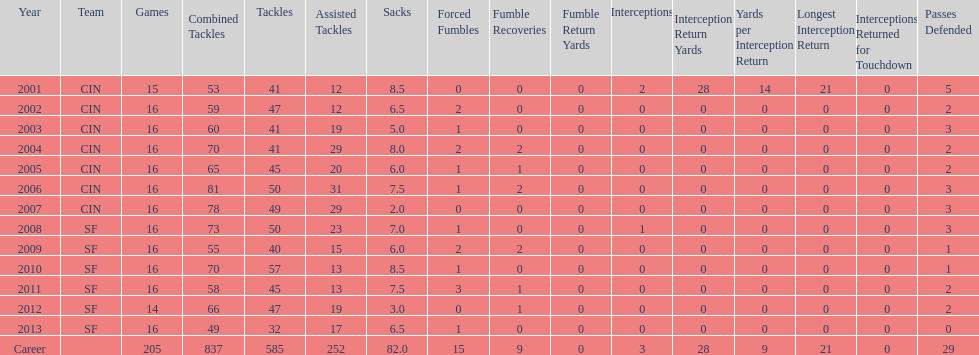In the initial five seasons, how many sacks did this player achieve? 34. Give me the full table as a dictionary. {'header': ['Year', 'Team', 'Games', 'Combined Tackles', 'Tackles', 'Assisted Tackles', 'Sacks', 'Forced Fumbles', 'Fumble Recoveries', 'Fumble Return Yards', 'Interceptions', 'Interception Return Yards', 'Yards per Interception Return', 'Longest Interception Return', 'Interceptions Returned for Touchdown', 'Passes Defended'], 'rows': [['2001', 'CIN', '15', '53', '41', '12', '8.5', '0', '0', '0', '2', '28', '14', '21', '0', '5'], ['2002', 'CIN', '16', '59', '47', '12', '6.5', '2', '0', '0', '0', '0', '0', '0', '0', '2'], ['2003', 'CIN', '16', '60', '41', '19', '5.0', '1', '0', '0', '0', '0', '0', '0', '0', '3'], ['2004', 'CIN', '16', '70', '41', '29', '8.0', '2', '2', '0', '0', '0', '0', '0', '0', '2'], ['2005', 'CIN', '16', '65', '45', '20', '6.0', '1', '1', '0', '0', '0', '0', '0', '0', '2'], ['2006', 'CIN', '16', '81', '50', '31', '7.5', '1', '2', '0', '0', '0', '0', '0', '0', '3'], ['2007', 'CIN', '16', '78', '49', '29', '2.0', '0', '0', '0', '0', '0', '0', '0', '0', '3'], ['2008', 'SF', '16', '73', '50', '23', '7.0', '1', '0', '0', '1', '0', '0', '0', '0', '3'], ['2009', 'SF', '16', '55', '40', '15', '6.0', '2', '2', '0', '0', '0', '0', '0', '0', '1'], ['2010', 'SF', '16', '70', '57', '13', '8.5', '1', '0', '0', '0', '0', '0', '0', '0', '1'], ['2011', 'SF', '16', '58', '45', '13', '7.5', '3', '1', '0', '0', '0', '0', '0', '0', '2'], ['2012', 'SF', '14', '66', '47', '19', '3.0', '0', '1', '0', '0', '0', '0', '0', '0', '2'], ['2013', 'SF', '16', '49', '32', '17', '6.5', '1', '0', '0', '0', '0', '0', '0', '0', '0'], ['Career', '', '205', '837', '585', '252', '82.0', '15', '9', '0', '3', '28', '9', '21', '0', '29']]} 